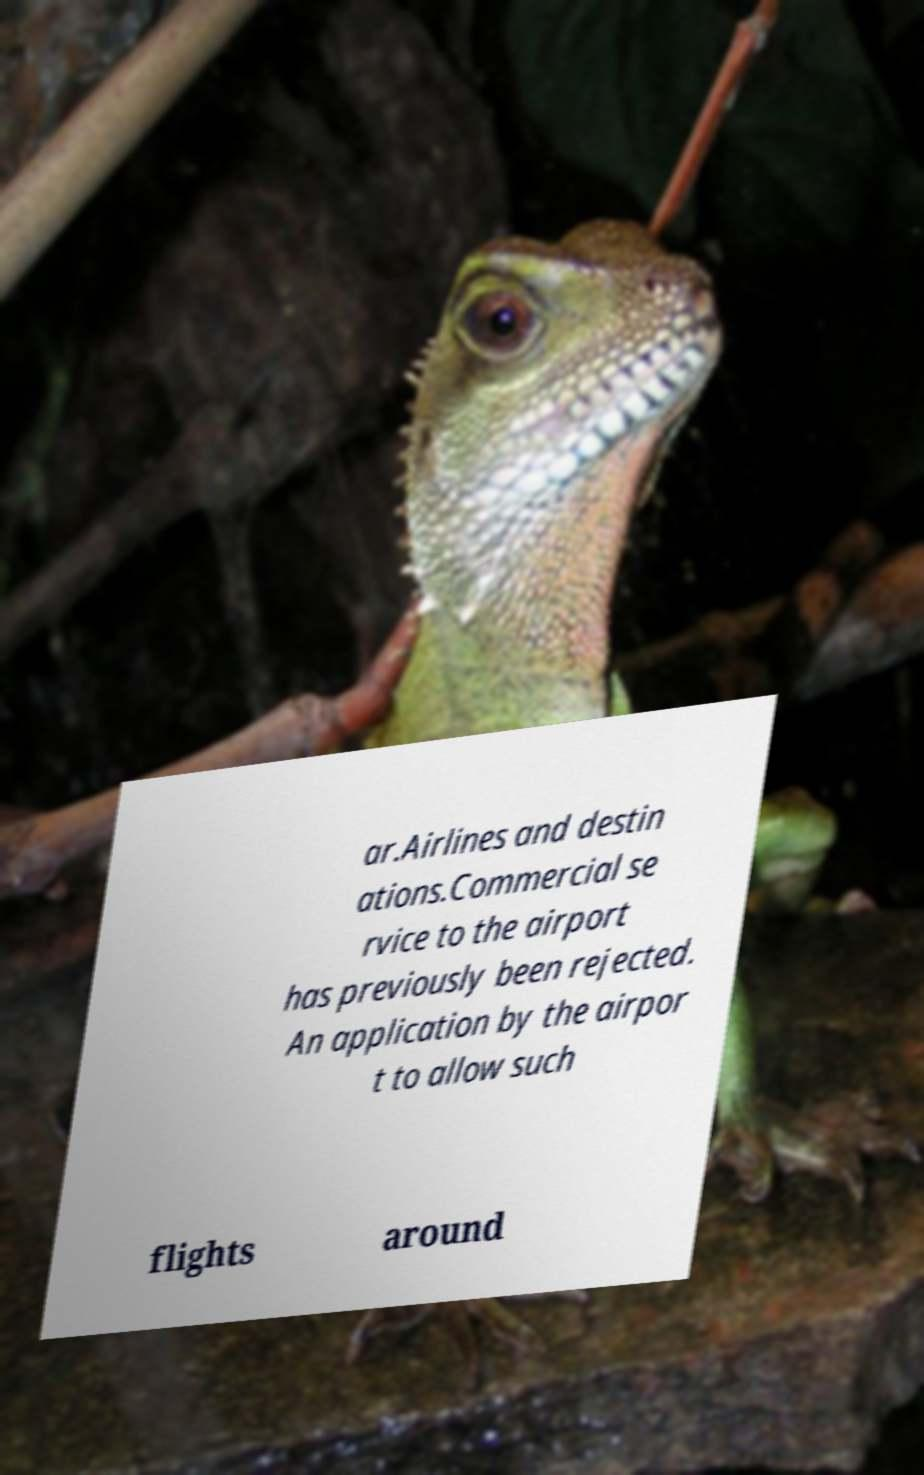There's text embedded in this image that I need extracted. Can you transcribe it verbatim? ar.Airlines and destin ations.Commercial se rvice to the airport has previously been rejected. An application by the airpor t to allow such flights around 